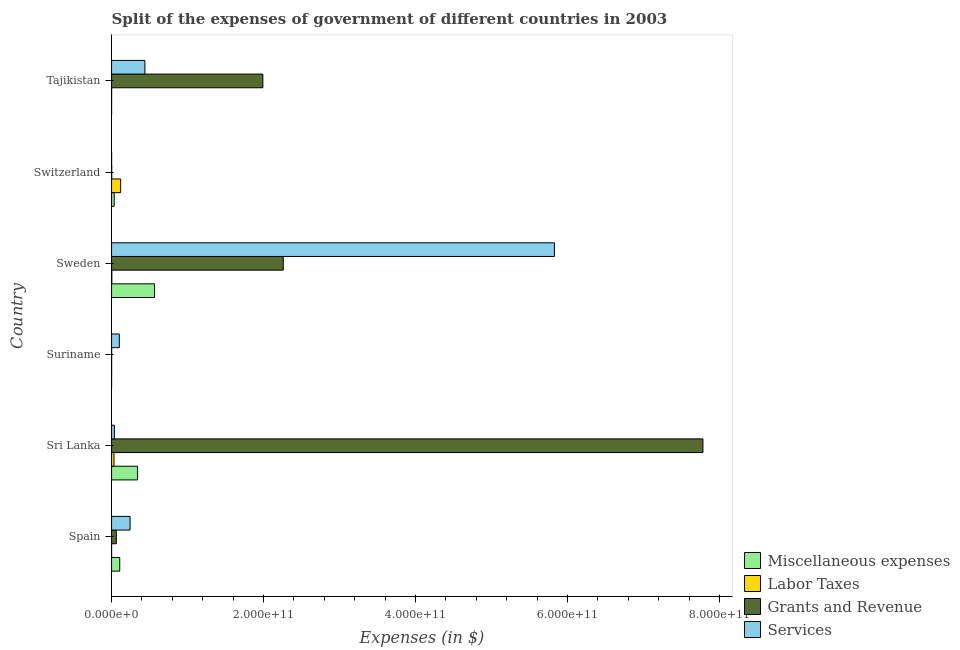How many different coloured bars are there?
Your response must be concise. 4. How many groups of bars are there?
Ensure brevity in your answer.  6. Are the number of bars per tick equal to the number of legend labels?
Make the answer very short. Yes. What is the label of the 2nd group of bars from the top?
Offer a very short reply. Switzerland. What is the amount spent on services in Sri Lanka?
Give a very brief answer. 3.75e+09. Across all countries, what is the maximum amount spent on labor taxes?
Your answer should be compact. 1.20e+1. Across all countries, what is the minimum amount spent on miscellaneous expenses?
Your answer should be compact. 4.59e+07. In which country was the amount spent on labor taxes maximum?
Ensure brevity in your answer.  Switzerland. In which country was the amount spent on grants and revenue minimum?
Offer a terse response. Suriname. What is the total amount spent on grants and revenue in the graph?
Offer a very short reply. 1.21e+12. What is the difference between the amount spent on services in Spain and that in Sri Lanka?
Ensure brevity in your answer.  2.06e+1. What is the difference between the amount spent on grants and revenue in Suriname and the amount spent on labor taxes in Tajikistan?
Ensure brevity in your answer.  3.47e+07. What is the average amount spent on labor taxes per country?
Give a very brief answer. 2.62e+09. What is the difference between the amount spent on grants and revenue and amount spent on labor taxes in Tajikistan?
Make the answer very short. 1.99e+11. In how many countries, is the amount spent on grants and revenue greater than 400000000000 $?
Provide a short and direct response. 1. What is the ratio of the amount spent on labor taxes in Switzerland to that in Tajikistan?
Keep it short and to the point. 125.86. Is the difference between the amount spent on grants and revenue in Sri Lanka and Sweden greater than the difference between the amount spent on services in Sri Lanka and Sweden?
Give a very brief answer. Yes. What is the difference between the highest and the second highest amount spent on services?
Your response must be concise. 5.39e+11. What is the difference between the highest and the lowest amount spent on services?
Keep it short and to the point. 5.83e+11. What does the 4th bar from the top in Spain represents?
Ensure brevity in your answer.  Miscellaneous expenses. What does the 3rd bar from the bottom in Sweden represents?
Ensure brevity in your answer.  Grants and Revenue. Are all the bars in the graph horizontal?
Make the answer very short. Yes. What is the difference between two consecutive major ticks on the X-axis?
Your answer should be compact. 2.00e+11. Does the graph contain any zero values?
Your answer should be compact. No. Does the graph contain grids?
Keep it short and to the point. No. Where does the legend appear in the graph?
Provide a short and direct response. Bottom right. How many legend labels are there?
Your response must be concise. 4. How are the legend labels stacked?
Keep it short and to the point. Vertical. What is the title of the graph?
Your answer should be compact. Split of the expenses of government of different countries in 2003. What is the label or title of the X-axis?
Provide a succinct answer. Expenses (in $). What is the label or title of the Y-axis?
Make the answer very short. Country. What is the Expenses (in $) in Miscellaneous expenses in Spain?
Keep it short and to the point. 1.08e+1. What is the Expenses (in $) in Labor Taxes in Spain?
Provide a short and direct response. 2.98e+07. What is the Expenses (in $) of Grants and Revenue in Spain?
Give a very brief answer. 6.27e+09. What is the Expenses (in $) in Services in Spain?
Offer a terse response. 2.44e+1. What is the Expenses (in $) of Miscellaneous expenses in Sri Lanka?
Your response must be concise. 3.42e+1. What is the Expenses (in $) of Labor Taxes in Sri Lanka?
Your response must be concise. 3.19e+09. What is the Expenses (in $) of Grants and Revenue in Sri Lanka?
Offer a very short reply. 7.78e+11. What is the Expenses (in $) in Services in Sri Lanka?
Offer a very short reply. 3.75e+09. What is the Expenses (in $) in Miscellaneous expenses in Suriname?
Your answer should be very brief. 4.59e+07. What is the Expenses (in $) of Labor Taxes in Suriname?
Offer a very short reply. 8.67e+07. What is the Expenses (in $) in Grants and Revenue in Suriname?
Keep it short and to the point. 1.30e+08. What is the Expenses (in $) of Services in Suriname?
Your response must be concise. 1.02e+1. What is the Expenses (in $) of Miscellaneous expenses in Sweden?
Your answer should be very brief. 5.66e+1. What is the Expenses (in $) of Labor Taxes in Sweden?
Make the answer very short. 3.64e+08. What is the Expenses (in $) in Grants and Revenue in Sweden?
Offer a terse response. 2.26e+11. What is the Expenses (in $) in Services in Sweden?
Offer a very short reply. 5.83e+11. What is the Expenses (in $) in Miscellaneous expenses in Switzerland?
Offer a terse response. 3.46e+09. What is the Expenses (in $) of Labor Taxes in Switzerland?
Offer a very short reply. 1.20e+1. What is the Expenses (in $) in Grants and Revenue in Switzerland?
Your response must be concise. 2.39e+08. What is the Expenses (in $) in Services in Switzerland?
Ensure brevity in your answer.  8.06e+07. What is the Expenses (in $) of Miscellaneous expenses in Tajikistan?
Provide a succinct answer. 5.62e+07. What is the Expenses (in $) of Labor Taxes in Tajikistan?
Your response must be concise. 9.50e+07. What is the Expenses (in $) of Grants and Revenue in Tajikistan?
Provide a short and direct response. 1.99e+11. What is the Expenses (in $) of Services in Tajikistan?
Keep it short and to the point. 4.39e+1. Across all countries, what is the maximum Expenses (in $) in Miscellaneous expenses?
Make the answer very short. 5.66e+1. Across all countries, what is the maximum Expenses (in $) of Labor Taxes?
Offer a terse response. 1.20e+1. Across all countries, what is the maximum Expenses (in $) of Grants and Revenue?
Your answer should be very brief. 7.78e+11. Across all countries, what is the maximum Expenses (in $) in Services?
Your response must be concise. 5.83e+11. Across all countries, what is the minimum Expenses (in $) in Miscellaneous expenses?
Offer a very short reply. 4.59e+07. Across all countries, what is the minimum Expenses (in $) of Labor Taxes?
Ensure brevity in your answer.  2.98e+07. Across all countries, what is the minimum Expenses (in $) of Grants and Revenue?
Offer a terse response. 1.30e+08. Across all countries, what is the minimum Expenses (in $) of Services?
Give a very brief answer. 8.06e+07. What is the total Expenses (in $) of Miscellaneous expenses in the graph?
Provide a succinct answer. 1.05e+11. What is the total Expenses (in $) of Labor Taxes in the graph?
Offer a terse response. 1.57e+1. What is the total Expenses (in $) of Grants and Revenue in the graph?
Your answer should be compact. 1.21e+12. What is the total Expenses (in $) of Services in the graph?
Your answer should be very brief. 6.65e+11. What is the difference between the Expenses (in $) in Miscellaneous expenses in Spain and that in Sri Lanka?
Your answer should be compact. -2.35e+1. What is the difference between the Expenses (in $) of Labor Taxes in Spain and that in Sri Lanka?
Your answer should be compact. -3.16e+09. What is the difference between the Expenses (in $) in Grants and Revenue in Spain and that in Sri Lanka?
Ensure brevity in your answer.  -7.72e+11. What is the difference between the Expenses (in $) of Services in Spain and that in Sri Lanka?
Keep it short and to the point. 2.06e+1. What is the difference between the Expenses (in $) of Miscellaneous expenses in Spain and that in Suriname?
Ensure brevity in your answer.  1.07e+1. What is the difference between the Expenses (in $) in Labor Taxes in Spain and that in Suriname?
Make the answer very short. -5.69e+07. What is the difference between the Expenses (in $) in Grants and Revenue in Spain and that in Suriname?
Ensure brevity in your answer.  6.14e+09. What is the difference between the Expenses (in $) of Services in Spain and that in Suriname?
Provide a short and direct response. 1.42e+1. What is the difference between the Expenses (in $) in Miscellaneous expenses in Spain and that in Sweden?
Provide a succinct answer. -4.58e+1. What is the difference between the Expenses (in $) in Labor Taxes in Spain and that in Sweden?
Your answer should be compact. -3.34e+08. What is the difference between the Expenses (in $) of Grants and Revenue in Spain and that in Sweden?
Ensure brevity in your answer.  -2.20e+11. What is the difference between the Expenses (in $) of Services in Spain and that in Sweden?
Offer a very short reply. -5.58e+11. What is the difference between the Expenses (in $) in Miscellaneous expenses in Spain and that in Switzerland?
Ensure brevity in your answer.  7.30e+09. What is the difference between the Expenses (in $) of Labor Taxes in Spain and that in Switzerland?
Offer a very short reply. -1.19e+1. What is the difference between the Expenses (in $) of Grants and Revenue in Spain and that in Switzerland?
Offer a very short reply. 6.04e+09. What is the difference between the Expenses (in $) of Services in Spain and that in Switzerland?
Give a very brief answer. 2.43e+1. What is the difference between the Expenses (in $) in Miscellaneous expenses in Spain and that in Tajikistan?
Offer a terse response. 1.07e+1. What is the difference between the Expenses (in $) in Labor Taxes in Spain and that in Tajikistan?
Your response must be concise. -6.52e+07. What is the difference between the Expenses (in $) of Grants and Revenue in Spain and that in Tajikistan?
Your response must be concise. -1.93e+11. What is the difference between the Expenses (in $) in Services in Spain and that in Tajikistan?
Make the answer very short. -1.95e+1. What is the difference between the Expenses (in $) of Miscellaneous expenses in Sri Lanka and that in Suriname?
Keep it short and to the point. 3.42e+1. What is the difference between the Expenses (in $) of Labor Taxes in Sri Lanka and that in Suriname?
Make the answer very short. 3.11e+09. What is the difference between the Expenses (in $) of Grants and Revenue in Sri Lanka and that in Suriname?
Your answer should be compact. 7.78e+11. What is the difference between the Expenses (in $) in Services in Sri Lanka and that in Suriname?
Give a very brief answer. -6.46e+09. What is the difference between the Expenses (in $) in Miscellaneous expenses in Sri Lanka and that in Sweden?
Give a very brief answer. -2.24e+1. What is the difference between the Expenses (in $) in Labor Taxes in Sri Lanka and that in Sweden?
Offer a terse response. 2.83e+09. What is the difference between the Expenses (in $) in Grants and Revenue in Sri Lanka and that in Sweden?
Ensure brevity in your answer.  5.52e+11. What is the difference between the Expenses (in $) of Services in Sri Lanka and that in Sweden?
Give a very brief answer. -5.79e+11. What is the difference between the Expenses (in $) of Miscellaneous expenses in Sri Lanka and that in Switzerland?
Give a very brief answer. 3.08e+1. What is the difference between the Expenses (in $) of Labor Taxes in Sri Lanka and that in Switzerland?
Give a very brief answer. -8.76e+09. What is the difference between the Expenses (in $) of Grants and Revenue in Sri Lanka and that in Switzerland?
Keep it short and to the point. 7.78e+11. What is the difference between the Expenses (in $) in Services in Sri Lanka and that in Switzerland?
Ensure brevity in your answer.  3.67e+09. What is the difference between the Expenses (in $) in Miscellaneous expenses in Sri Lanka and that in Tajikistan?
Ensure brevity in your answer.  3.42e+1. What is the difference between the Expenses (in $) of Labor Taxes in Sri Lanka and that in Tajikistan?
Your answer should be very brief. 3.10e+09. What is the difference between the Expenses (in $) of Grants and Revenue in Sri Lanka and that in Tajikistan?
Your answer should be very brief. 5.79e+11. What is the difference between the Expenses (in $) of Services in Sri Lanka and that in Tajikistan?
Provide a short and direct response. -4.01e+1. What is the difference between the Expenses (in $) in Miscellaneous expenses in Suriname and that in Sweden?
Keep it short and to the point. -5.65e+1. What is the difference between the Expenses (in $) of Labor Taxes in Suriname and that in Sweden?
Provide a short and direct response. -2.77e+08. What is the difference between the Expenses (in $) of Grants and Revenue in Suriname and that in Sweden?
Keep it short and to the point. -2.26e+11. What is the difference between the Expenses (in $) of Services in Suriname and that in Sweden?
Offer a terse response. -5.72e+11. What is the difference between the Expenses (in $) of Miscellaneous expenses in Suriname and that in Switzerland?
Give a very brief answer. -3.42e+09. What is the difference between the Expenses (in $) of Labor Taxes in Suriname and that in Switzerland?
Give a very brief answer. -1.19e+1. What is the difference between the Expenses (in $) of Grants and Revenue in Suriname and that in Switzerland?
Provide a short and direct response. -1.09e+08. What is the difference between the Expenses (in $) in Services in Suriname and that in Switzerland?
Your answer should be very brief. 1.01e+1. What is the difference between the Expenses (in $) of Miscellaneous expenses in Suriname and that in Tajikistan?
Provide a succinct answer. -1.03e+07. What is the difference between the Expenses (in $) of Labor Taxes in Suriname and that in Tajikistan?
Offer a terse response. -8.30e+06. What is the difference between the Expenses (in $) of Grants and Revenue in Suriname and that in Tajikistan?
Keep it short and to the point. -1.99e+11. What is the difference between the Expenses (in $) of Services in Suriname and that in Tajikistan?
Offer a very short reply. -3.37e+1. What is the difference between the Expenses (in $) of Miscellaneous expenses in Sweden and that in Switzerland?
Your answer should be compact. 5.31e+1. What is the difference between the Expenses (in $) in Labor Taxes in Sweden and that in Switzerland?
Give a very brief answer. -1.16e+1. What is the difference between the Expenses (in $) in Grants and Revenue in Sweden and that in Switzerland?
Your answer should be compact. 2.26e+11. What is the difference between the Expenses (in $) of Services in Sweden and that in Switzerland?
Your answer should be very brief. 5.83e+11. What is the difference between the Expenses (in $) of Miscellaneous expenses in Sweden and that in Tajikistan?
Offer a terse response. 5.65e+1. What is the difference between the Expenses (in $) in Labor Taxes in Sweden and that in Tajikistan?
Ensure brevity in your answer.  2.69e+08. What is the difference between the Expenses (in $) in Grants and Revenue in Sweden and that in Tajikistan?
Offer a terse response. 2.68e+1. What is the difference between the Expenses (in $) in Services in Sweden and that in Tajikistan?
Give a very brief answer. 5.39e+11. What is the difference between the Expenses (in $) in Miscellaneous expenses in Switzerland and that in Tajikistan?
Your answer should be very brief. 3.41e+09. What is the difference between the Expenses (in $) in Labor Taxes in Switzerland and that in Tajikistan?
Keep it short and to the point. 1.19e+1. What is the difference between the Expenses (in $) of Grants and Revenue in Switzerland and that in Tajikistan?
Make the answer very short. -1.99e+11. What is the difference between the Expenses (in $) in Services in Switzerland and that in Tajikistan?
Your answer should be very brief. -4.38e+1. What is the difference between the Expenses (in $) in Miscellaneous expenses in Spain and the Expenses (in $) in Labor Taxes in Sri Lanka?
Your response must be concise. 7.57e+09. What is the difference between the Expenses (in $) of Miscellaneous expenses in Spain and the Expenses (in $) of Grants and Revenue in Sri Lanka?
Give a very brief answer. -7.67e+11. What is the difference between the Expenses (in $) in Miscellaneous expenses in Spain and the Expenses (in $) in Services in Sri Lanka?
Your answer should be very brief. 7.01e+09. What is the difference between the Expenses (in $) in Labor Taxes in Spain and the Expenses (in $) in Grants and Revenue in Sri Lanka?
Provide a short and direct response. -7.78e+11. What is the difference between the Expenses (in $) of Labor Taxes in Spain and the Expenses (in $) of Services in Sri Lanka?
Provide a short and direct response. -3.72e+09. What is the difference between the Expenses (in $) of Grants and Revenue in Spain and the Expenses (in $) of Services in Sri Lanka?
Provide a succinct answer. 2.52e+09. What is the difference between the Expenses (in $) in Miscellaneous expenses in Spain and the Expenses (in $) in Labor Taxes in Suriname?
Your response must be concise. 1.07e+1. What is the difference between the Expenses (in $) of Miscellaneous expenses in Spain and the Expenses (in $) of Grants and Revenue in Suriname?
Your answer should be compact. 1.06e+1. What is the difference between the Expenses (in $) in Miscellaneous expenses in Spain and the Expenses (in $) in Services in Suriname?
Offer a terse response. 5.50e+08. What is the difference between the Expenses (in $) of Labor Taxes in Spain and the Expenses (in $) of Grants and Revenue in Suriname?
Provide a short and direct response. -9.99e+07. What is the difference between the Expenses (in $) in Labor Taxes in Spain and the Expenses (in $) in Services in Suriname?
Provide a succinct answer. -1.02e+1. What is the difference between the Expenses (in $) in Grants and Revenue in Spain and the Expenses (in $) in Services in Suriname?
Give a very brief answer. -3.94e+09. What is the difference between the Expenses (in $) of Miscellaneous expenses in Spain and the Expenses (in $) of Labor Taxes in Sweden?
Make the answer very short. 1.04e+1. What is the difference between the Expenses (in $) of Miscellaneous expenses in Spain and the Expenses (in $) of Grants and Revenue in Sweden?
Offer a very short reply. -2.15e+11. What is the difference between the Expenses (in $) of Miscellaneous expenses in Spain and the Expenses (in $) of Services in Sweden?
Keep it short and to the point. -5.72e+11. What is the difference between the Expenses (in $) in Labor Taxes in Spain and the Expenses (in $) in Grants and Revenue in Sweden?
Your response must be concise. -2.26e+11. What is the difference between the Expenses (in $) of Labor Taxes in Spain and the Expenses (in $) of Services in Sweden?
Your answer should be very brief. -5.83e+11. What is the difference between the Expenses (in $) of Grants and Revenue in Spain and the Expenses (in $) of Services in Sweden?
Offer a terse response. -5.76e+11. What is the difference between the Expenses (in $) of Miscellaneous expenses in Spain and the Expenses (in $) of Labor Taxes in Switzerland?
Make the answer very short. -1.20e+09. What is the difference between the Expenses (in $) of Miscellaneous expenses in Spain and the Expenses (in $) of Grants and Revenue in Switzerland?
Give a very brief answer. 1.05e+1. What is the difference between the Expenses (in $) of Miscellaneous expenses in Spain and the Expenses (in $) of Services in Switzerland?
Ensure brevity in your answer.  1.07e+1. What is the difference between the Expenses (in $) of Labor Taxes in Spain and the Expenses (in $) of Grants and Revenue in Switzerland?
Offer a terse response. -2.09e+08. What is the difference between the Expenses (in $) in Labor Taxes in Spain and the Expenses (in $) in Services in Switzerland?
Provide a succinct answer. -5.08e+07. What is the difference between the Expenses (in $) of Grants and Revenue in Spain and the Expenses (in $) of Services in Switzerland?
Keep it short and to the point. 6.19e+09. What is the difference between the Expenses (in $) of Miscellaneous expenses in Spain and the Expenses (in $) of Labor Taxes in Tajikistan?
Give a very brief answer. 1.07e+1. What is the difference between the Expenses (in $) in Miscellaneous expenses in Spain and the Expenses (in $) in Grants and Revenue in Tajikistan?
Make the answer very short. -1.88e+11. What is the difference between the Expenses (in $) in Miscellaneous expenses in Spain and the Expenses (in $) in Services in Tajikistan?
Keep it short and to the point. -3.31e+1. What is the difference between the Expenses (in $) of Labor Taxes in Spain and the Expenses (in $) of Grants and Revenue in Tajikistan?
Offer a terse response. -1.99e+11. What is the difference between the Expenses (in $) in Labor Taxes in Spain and the Expenses (in $) in Services in Tajikistan?
Your answer should be compact. -4.38e+1. What is the difference between the Expenses (in $) in Grants and Revenue in Spain and the Expenses (in $) in Services in Tajikistan?
Provide a succinct answer. -3.76e+1. What is the difference between the Expenses (in $) of Miscellaneous expenses in Sri Lanka and the Expenses (in $) of Labor Taxes in Suriname?
Keep it short and to the point. 3.41e+1. What is the difference between the Expenses (in $) of Miscellaneous expenses in Sri Lanka and the Expenses (in $) of Grants and Revenue in Suriname?
Your response must be concise. 3.41e+1. What is the difference between the Expenses (in $) in Miscellaneous expenses in Sri Lanka and the Expenses (in $) in Services in Suriname?
Your answer should be very brief. 2.40e+1. What is the difference between the Expenses (in $) of Labor Taxes in Sri Lanka and the Expenses (in $) of Grants and Revenue in Suriname?
Provide a succinct answer. 3.06e+09. What is the difference between the Expenses (in $) of Labor Taxes in Sri Lanka and the Expenses (in $) of Services in Suriname?
Provide a short and direct response. -7.02e+09. What is the difference between the Expenses (in $) in Grants and Revenue in Sri Lanka and the Expenses (in $) in Services in Suriname?
Keep it short and to the point. 7.68e+11. What is the difference between the Expenses (in $) of Miscellaneous expenses in Sri Lanka and the Expenses (in $) of Labor Taxes in Sweden?
Your answer should be very brief. 3.39e+1. What is the difference between the Expenses (in $) in Miscellaneous expenses in Sri Lanka and the Expenses (in $) in Grants and Revenue in Sweden?
Keep it short and to the point. -1.92e+11. What is the difference between the Expenses (in $) in Miscellaneous expenses in Sri Lanka and the Expenses (in $) in Services in Sweden?
Offer a very short reply. -5.48e+11. What is the difference between the Expenses (in $) of Labor Taxes in Sri Lanka and the Expenses (in $) of Grants and Revenue in Sweden?
Keep it short and to the point. -2.23e+11. What is the difference between the Expenses (in $) in Labor Taxes in Sri Lanka and the Expenses (in $) in Services in Sweden?
Keep it short and to the point. -5.79e+11. What is the difference between the Expenses (in $) of Grants and Revenue in Sri Lanka and the Expenses (in $) of Services in Sweden?
Provide a short and direct response. 1.95e+11. What is the difference between the Expenses (in $) of Miscellaneous expenses in Sri Lanka and the Expenses (in $) of Labor Taxes in Switzerland?
Ensure brevity in your answer.  2.23e+1. What is the difference between the Expenses (in $) of Miscellaneous expenses in Sri Lanka and the Expenses (in $) of Grants and Revenue in Switzerland?
Your answer should be very brief. 3.40e+1. What is the difference between the Expenses (in $) of Miscellaneous expenses in Sri Lanka and the Expenses (in $) of Services in Switzerland?
Make the answer very short. 3.42e+1. What is the difference between the Expenses (in $) of Labor Taxes in Sri Lanka and the Expenses (in $) of Grants and Revenue in Switzerland?
Your response must be concise. 2.96e+09. What is the difference between the Expenses (in $) of Labor Taxes in Sri Lanka and the Expenses (in $) of Services in Switzerland?
Ensure brevity in your answer.  3.11e+09. What is the difference between the Expenses (in $) in Grants and Revenue in Sri Lanka and the Expenses (in $) in Services in Switzerland?
Ensure brevity in your answer.  7.78e+11. What is the difference between the Expenses (in $) in Miscellaneous expenses in Sri Lanka and the Expenses (in $) in Labor Taxes in Tajikistan?
Your response must be concise. 3.41e+1. What is the difference between the Expenses (in $) of Miscellaneous expenses in Sri Lanka and the Expenses (in $) of Grants and Revenue in Tajikistan?
Make the answer very short. -1.65e+11. What is the difference between the Expenses (in $) in Miscellaneous expenses in Sri Lanka and the Expenses (in $) in Services in Tajikistan?
Offer a terse response. -9.63e+09. What is the difference between the Expenses (in $) in Labor Taxes in Sri Lanka and the Expenses (in $) in Grants and Revenue in Tajikistan?
Offer a terse response. -1.96e+11. What is the difference between the Expenses (in $) in Labor Taxes in Sri Lanka and the Expenses (in $) in Services in Tajikistan?
Provide a succinct answer. -4.07e+1. What is the difference between the Expenses (in $) in Grants and Revenue in Sri Lanka and the Expenses (in $) in Services in Tajikistan?
Make the answer very short. 7.34e+11. What is the difference between the Expenses (in $) of Miscellaneous expenses in Suriname and the Expenses (in $) of Labor Taxes in Sweden?
Your answer should be compact. -3.18e+08. What is the difference between the Expenses (in $) of Miscellaneous expenses in Suriname and the Expenses (in $) of Grants and Revenue in Sweden?
Your answer should be very brief. -2.26e+11. What is the difference between the Expenses (in $) of Miscellaneous expenses in Suriname and the Expenses (in $) of Services in Sweden?
Keep it short and to the point. -5.83e+11. What is the difference between the Expenses (in $) of Labor Taxes in Suriname and the Expenses (in $) of Grants and Revenue in Sweden?
Provide a short and direct response. -2.26e+11. What is the difference between the Expenses (in $) of Labor Taxes in Suriname and the Expenses (in $) of Services in Sweden?
Make the answer very short. -5.83e+11. What is the difference between the Expenses (in $) of Grants and Revenue in Suriname and the Expenses (in $) of Services in Sweden?
Make the answer very short. -5.83e+11. What is the difference between the Expenses (in $) of Miscellaneous expenses in Suriname and the Expenses (in $) of Labor Taxes in Switzerland?
Your response must be concise. -1.19e+1. What is the difference between the Expenses (in $) of Miscellaneous expenses in Suriname and the Expenses (in $) of Grants and Revenue in Switzerland?
Give a very brief answer. -1.93e+08. What is the difference between the Expenses (in $) in Miscellaneous expenses in Suriname and the Expenses (in $) in Services in Switzerland?
Ensure brevity in your answer.  -3.48e+07. What is the difference between the Expenses (in $) in Labor Taxes in Suriname and the Expenses (in $) in Grants and Revenue in Switzerland?
Your answer should be compact. -1.52e+08. What is the difference between the Expenses (in $) in Labor Taxes in Suriname and the Expenses (in $) in Services in Switzerland?
Give a very brief answer. 6.08e+06. What is the difference between the Expenses (in $) in Grants and Revenue in Suriname and the Expenses (in $) in Services in Switzerland?
Give a very brief answer. 4.91e+07. What is the difference between the Expenses (in $) in Miscellaneous expenses in Suriname and the Expenses (in $) in Labor Taxes in Tajikistan?
Your answer should be compact. -4.91e+07. What is the difference between the Expenses (in $) in Miscellaneous expenses in Suriname and the Expenses (in $) in Grants and Revenue in Tajikistan?
Offer a terse response. -1.99e+11. What is the difference between the Expenses (in $) in Miscellaneous expenses in Suriname and the Expenses (in $) in Services in Tajikistan?
Ensure brevity in your answer.  -4.38e+1. What is the difference between the Expenses (in $) of Labor Taxes in Suriname and the Expenses (in $) of Grants and Revenue in Tajikistan?
Provide a succinct answer. -1.99e+11. What is the difference between the Expenses (in $) in Labor Taxes in Suriname and the Expenses (in $) in Services in Tajikistan?
Provide a succinct answer. -4.38e+1. What is the difference between the Expenses (in $) in Grants and Revenue in Suriname and the Expenses (in $) in Services in Tajikistan?
Make the answer very short. -4.37e+1. What is the difference between the Expenses (in $) of Miscellaneous expenses in Sweden and the Expenses (in $) of Labor Taxes in Switzerland?
Provide a succinct answer. 4.46e+1. What is the difference between the Expenses (in $) in Miscellaneous expenses in Sweden and the Expenses (in $) in Grants and Revenue in Switzerland?
Keep it short and to the point. 5.64e+1. What is the difference between the Expenses (in $) in Miscellaneous expenses in Sweden and the Expenses (in $) in Services in Switzerland?
Ensure brevity in your answer.  5.65e+1. What is the difference between the Expenses (in $) in Labor Taxes in Sweden and the Expenses (in $) in Grants and Revenue in Switzerland?
Offer a very short reply. 1.25e+08. What is the difference between the Expenses (in $) in Labor Taxes in Sweden and the Expenses (in $) in Services in Switzerland?
Your answer should be very brief. 2.83e+08. What is the difference between the Expenses (in $) in Grants and Revenue in Sweden and the Expenses (in $) in Services in Switzerland?
Keep it short and to the point. 2.26e+11. What is the difference between the Expenses (in $) of Miscellaneous expenses in Sweden and the Expenses (in $) of Labor Taxes in Tajikistan?
Provide a succinct answer. 5.65e+1. What is the difference between the Expenses (in $) of Miscellaneous expenses in Sweden and the Expenses (in $) of Grants and Revenue in Tajikistan?
Your answer should be very brief. -1.42e+11. What is the difference between the Expenses (in $) of Miscellaneous expenses in Sweden and the Expenses (in $) of Services in Tajikistan?
Your response must be concise. 1.27e+1. What is the difference between the Expenses (in $) in Labor Taxes in Sweden and the Expenses (in $) in Grants and Revenue in Tajikistan?
Offer a very short reply. -1.99e+11. What is the difference between the Expenses (in $) in Labor Taxes in Sweden and the Expenses (in $) in Services in Tajikistan?
Provide a succinct answer. -4.35e+1. What is the difference between the Expenses (in $) of Grants and Revenue in Sweden and the Expenses (in $) of Services in Tajikistan?
Ensure brevity in your answer.  1.82e+11. What is the difference between the Expenses (in $) of Miscellaneous expenses in Switzerland and the Expenses (in $) of Labor Taxes in Tajikistan?
Make the answer very short. 3.37e+09. What is the difference between the Expenses (in $) of Miscellaneous expenses in Switzerland and the Expenses (in $) of Grants and Revenue in Tajikistan?
Your response must be concise. -1.96e+11. What is the difference between the Expenses (in $) in Miscellaneous expenses in Switzerland and the Expenses (in $) in Services in Tajikistan?
Give a very brief answer. -4.04e+1. What is the difference between the Expenses (in $) of Labor Taxes in Switzerland and the Expenses (in $) of Grants and Revenue in Tajikistan?
Give a very brief answer. -1.87e+11. What is the difference between the Expenses (in $) in Labor Taxes in Switzerland and the Expenses (in $) in Services in Tajikistan?
Your answer should be compact. -3.19e+1. What is the difference between the Expenses (in $) of Grants and Revenue in Switzerland and the Expenses (in $) of Services in Tajikistan?
Offer a terse response. -4.36e+1. What is the average Expenses (in $) of Miscellaneous expenses per country?
Ensure brevity in your answer.  1.75e+1. What is the average Expenses (in $) in Labor Taxes per country?
Your answer should be very brief. 2.62e+09. What is the average Expenses (in $) of Grants and Revenue per country?
Your answer should be very brief. 2.02e+11. What is the average Expenses (in $) in Services per country?
Provide a short and direct response. 1.11e+11. What is the difference between the Expenses (in $) of Miscellaneous expenses and Expenses (in $) of Labor Taxes in Spain?
Give a very brief answer. 1.07e+1. What is the difference between the Expenses (in $) of Miscellaneous expenses and Expenses (in $) of Grants and Revenue in Spain?
Ensure brevity in your answer.  4.49e+09. What is the difference between the Expenses (in $) in Miscellaneous expenses and Expenses (in $) in Services in Spain?
Ensure brevity in your answer.  -1.36e+1. What is the difference between the Expenses (in $) of Labor Taxes and Expenses (in $) of Grants and Revenue in Spain?
Keep it short and to the point. -6.24e+09. What is the difference between the Expenses (in $) of Labor Taxes and Expenses (in $) of Services in Spain?
Make the answer very short. -2.43e+1. What is the difference between the Expenses (in $) in Grants and Revenue and Expenses (in $) in Services in Spain?
Your answer should be compact. -1.81e+1. What is the difference between the Expenses (in $) in Miscellaneous expenses and Expenses (in $) in Labor Taxes in Sri Lanka?
Your answer should be compact. 3.10e+1. What is the difference between the Expenses (in $) in Miscellaneous expenses and Expenses (in $) in Grants and Revenue in Sri Lanka?
Provide a short and direct response. -7.44e+11. What is the difference between the Expenses (in $) in Miscellaneous expenses and Expenses (in $) in Services in Sri Lanka?
Provide a short and direct response. 3.05e+1. What is the difference between the Expenses (in $) in Labor Taxes and Expenses (in $) in Grants and Revenue in Sri Lanka?
Offer a very short reply. -7.75e+11. What is the difference between the Expenses (in $) of Labor Taxes and Expenses (in $) of Services in Sri Lanka?
Offer a terse response. -5.60e+08. What is the difference between the Expenses (in $) in Grants and Revenue and Expenses (in $) in Services in Sri Lanka?
Keep it short and to the point. 7.74e+11. What is the difference between the Expenses (in $) of Miscellaneous expenses and Expenses (in $) of Labor Taxes in Suriname?
Your answer should be very brief. -4.08e+07. What is the difference between the Expenses (in $) in Miscellaneous expenses and Expenses (in $) in Grants and Revenue in Suriname?
Your response must be concise. -8.39e+07. What is the difference between the Expenses (in $) in Miscellaneous expenses and Expenses (in $) in Services in Suriname?
Your answer should be compact. -1.02e+1. What is the difference between the Expenses (in $) in Labor Taxes and Expenses (in $) in Grants and Revenue in Suriname?
Make the answer very short. -4.30e+07. What is the difference between the Expenses (in $) of Labor Taxes and Expenses (in $) of Services in Suriname?
Offer a very short reply. -1.01e+1. What is the difference between the Expenses (in $) of Grants and Revenue and Expenses (in $) of Services in Suriname?
Offer a very short reply. -1.01e+1. What is the difference between the Expenses (in $) in Miscellaneous expenses and Expenses (in $) in Labor Taxes in Sweden?
Make the answer very short. 5.62e+1. What is the difference between the Expenses (in $) of Miscellaneous expenses and Expenses (in $) of Grants and Revenue in Sweden?
Give a very brief answer. -1.69e+11. What is the difference between the Expenses (in $) in Miscellaneous expenses and Expenses (in $) in Services in Sweden?
Offer a very short reply. -5.26e+11. What is the difference between the Expenses (in $) in Labor Taxes and Expenses (in $) in Grants and Revenue in Sweden?
Give a very brief answer. -2.26e+11. What is the difference between the Expenses (in $) in Labor Taxes and Expenses (in $) in Services in Sweden?
Your response must be concise. -5.82e+11. What is the difference between the Expenses (in $) of Grants and Revenue and Expenses (in $) of Services in Sweden?
Make the answer very short. -3.57e+11. What is the difference between the Expenses (in $) of Miscellaneous expenses and Expenses (in $) of Labor Taxes in Switzerland?
Provide a short and direct response. -8.49e+09. What is the difference between the Expenses (in $) in Miscellaneous expenses and Expenses (in $) in Grants and Revenue in Switzerland?
Offer a terse response. 3.22e+09. What is the difference between the Expenses (in $) of Miscellaneous expenses and Expenses (in $) of Services in Switzerland?
Your answer should be very brief. 3.38e+09. What is the difference between the Expenses (in $) in Labor Taxes and Expenses (in $) in Grants and Revenue in Switzerland?
Provide a succinct answer. 1.17e+1. What is the difference between the Expenses (in $) of Labor Taxes and Expenses (in $) of Services in Switzerland?
Your answer should be very brief. 1.19e+1. What is the difference between the Expenses (in $) in Grants and Revenue and Expenses (in $) in Services in Switzerland?
Offer a very short reply. 1.58e+08. What is the difference between the Expenses (in $) of Miscellaneous expenses and Expenses (in $) of Labor Taxes in Tajikistan?
Make the answer very short. -3.88e+07. What is the difference between the Expenses (in $) in Miscellaneous expenses and Expenses (in $) in Grants and Revenue in Tajikistan?
Your answer should be compact. -1.99e+11. What is the difference between the Expenses (in $) in Miscellaneous expenses and Expenses (in $) in Services in Tajikistan?
Offer a very short reply. -4.38e+1. What is the difference between the Expenses (in $) in Labor Taxes and Expenses (in $) in Grants and Revenue in Tajikistan?
Provide a short and direct response. -1.99e+11. What is the difference between the Expenses (in $) in Labor Taxes and Expenses (in $) in Services in Tajikistan?
Offer a very short reply. -4.38e+1. What is the difference between the Expenses (in $) in Grants and Revenue and Expenses (in $) in Services in Tajikistan?
Offer a terse response. 1.55e+11. What is the ratio of the Expenses (in $) of Miscellaneous expenses in Spain to that in Sri Lanka?
Keep it short and to the point. 0.31. What is the ratio of the Expenses (in $) in Labor Taxes in Spain to that in Sri Lanka?
Your answer should be very brief. 0.01. What is the ratio of the Expenses (in $) of Grants and Revenue in Spain to that in Sri Lanka?
Your answer should be compact. 0.01. What is the ratio of the Expenses (in $) of Services in Spain to that in Sri Lanka?
Give a very brief answer. 6.49. What is the ratio of the Expenses (in $) of Miscellaneous expenses in Spain to that in Suriname?
Keep it short and to the point. 234.65. What is the ratio of the Expenses (in $) in Labor Taxes in Spain to that in Suriname?
Make the answer very short. 0.34. What is the ratio of the Expenses (in $) in Grants and Revenue in Spain to that in Suriname?
Give a very brief answer. 48.36. What is the ratio of the Expenses (in $) in Services in Spain to that in Suriname?
Provide a short and direct response. 2.39. What is the ratio of the Expenses (in $) of Miscellaneous expenses in Spain to that in Sweden?
Your answer should be compact. 0.19. What is the ratio of the Expenses (in $) in Labor Taxes in Spain to that in Sweden?
Offer a terse response. 0.08. What is the ratio of the Expenses (in $) in Grants and Revenue in Spain to that in Sweden?
Offer a terse response. 0.03. What is the ratio of the Expenses (in $) in Services in Spain to that in Sweden?
Your answer should be very brief. 0.04. What is the ratio of the Expenses (in $) in Miscellaneous expenses in Spain to that in Switzerland?
Ensure brevity in your answer.  3.11. What is the ratio of the Expenses (in $) of Labor Taxes in Spain to that in Switzerland?
Your answer should be compact. 0. What is the ratio of the Expenses (in $) of Grants and Revenue in Spain to that in Switzerland?
Your answer should be very brief. 26.28. What is the ratio of the Expenses (in $) of Services in Spain to that in Switzerland?
Offer a very short reply. 302.29. What is the ratio of the Expenses (in $) of Miscellaneous expenses in Spain to that in Tajikistan?
Offer a very short reply. 191.53. What is the ratio of the Expenses (in $) in Labor Taxes in Spain to that in Tajikistan?
Keep it short and to the point. 0.31. What is the ratio of the Expenses (in $) in Grants and Revenue in Spain to that in Tajikistan?
Your answer should be compact. 0.03. What is the ratio of the Expenses (in $) of Services in Spain to that in Tajikistan?
Ensure brevity in your answer.  0.56. What is the ratio of the Expenses (in $) of Miscellaneous expenses in Sri Lanka to that in Suriname?
Keep it short and to the point. 746.48. What is the ratio of the Expenses (in $) in Labor Taxes in Sri Lanka to that in Suriname?
Provide a succinct answer. 36.84. What is the ratio of the Expenses (in $) of Grants and Revenue in Sri Lanka to that in Suriname?
Provide a short and direct response. 5997.63. What is the ratio of the Expenses (in $) in Services in Sri Lanka to that in Suriname?
Offer a very short reply. 0.37. What is the ratio of the Expenses (in $) of Miscellaneous expenses in Sri Lanka to that in Sweden?
Keep it short and to the point. 0.6. What is the ratio of the Expenses (in $) of Labor Taxes in Sri Lanka to that in Sweden?
Your answer should be very brief. 8.79. What is the ratio of the Expenses (in $) in Grants and Revenue in Sri Lanka to that in Sweden?
Ensure brevity in your answer.  3.44. What is the ratio of the Expenses (in $) of Services in Sri Lanka to that in Sweden?
Offer a terse response. 0.01. What is the ratio of the Expenses (in $) of Miscellaneous expenses in Sri Lanka to that in Switzerland?
Your answer should be very brief. 9.89. What is the ratio of the Expenses (in $) in Labor Taxes in Sri Lanka to that in Switzerland?
Make the answer very short. 0.27. What is the ratio of the Expenses (in $) of Grants and Revenue in Sri Lanka to that in Switzerland?
Give a very brief answer. 3259.69. What is the ratio of the Expenses (in $) in Services in Sri Lanka to that in Switzerland?
Keep it short and to the point. 46.56. What is the ratio of the Expenses (in $) in Miscellaneous expenses in Sri Lanka to that in Tajikistan?
Ensure brevity in your answer.  609.29. What is the ratio of the Expenses (in $) of Labor Taxes in Sri Lanka to that in Tajikistan?
Your answer should be very brief. 33.62. What is the ratio of the Expenses (in $) of Grants and Revenue in Sri Lanka to that in Tajikistan?
Provide a short and direct response. 3.91. What is the ratio of the Expenses (in $) of Services in Sri Lanka to that in Tajikistan?
Your answer should be very brief. 0.09. What is the ratio of the Expenses (in $) in Miscellaneous expenses in Suriname to that in Sweden?
Make the answer very short. 0. What is the ratio of the Expenses (in $) of Labor Taxes in Suriname to that in Sweden?
Offer a terse response. 0.24. What is the ratio of the Expenses (in $) in Grants and Revenue in Suriname to that in Sweden?
Offer a terse response. 0. What is the ratio of the Expenses (in $) in Services in Suriname to that in Sweden?
Give a very brief answer. 0.02. What is the ratio of the Expenses (in $) in Miscellaneous expenses in Suriname to that in Switzerland?
Offer a very short reply. 0.01. What is the ratio of the Expenses (in $) of Labor Taxes in Suriname to that in Switzerland?
Offer a very short reply. 0.01. What is the ratio of the Expenses (in $) of Grants and Revenue in Suriname to that in Switzerland?
Keep it short and to the point. 0.54. What is the ratio of the Expenses (in $) of Services in Suriname to that in Switzerland?
Offer a terse response. 126.65. What is the ratio of the Expenses (in $) of Miscellaneous expenses in Suriname to that in Tajikistan?
Provide a short and direct response. 0.82. What is the ratio of the Expenses (in $) of Labor Taxes in Suriname to that in Tajikistan?
Offer a very short reply. 0.91. What is the ratio of the Expenses (in $) of Grants and Revenue in Suriname to that in Tajikistan?
Your answer should be very brief. 0. What is the ratio of the Expenses (in $) of Services in Suriname to that in Tajikistan?
Your answer should be very brief. 0.23. What is the ratio of the Expenses (in $) of Miscellaneous expenses in Sweden to that in Switzerland?
Provide a succinct answer. 16.34. What is the ratio of the Expenses (in $) of Labor Taxes in Sweden to that in Switzerland?
Make the answer very short. 0.03. What is the ratio of the Expenses (in $) in Grants and Revenue in Sweden to that in Switzerland?
Keep it short and to the point. 946.27. What is the ratio of the Expenses (in $) in Services in Sweden to that in Switzerland?
Your response must be concise. 7227.2. What is the ratio of the Expenses (in $) of Miscellaneous expenses in Sweden to that in Tajikistan?
Offer a terse response. 1007.26. What is the ratio of the Expenses (in $) of Labor Taxes in Sweden to that in Tajikistan?
Your answer should be very brief. 3.83. What is the ratio of the Expenses (in $) in Grants and Revenue in Sweden to that in Tajikistan?
Your answer should be compact. 1.13. What is the ratio of the Expenses (in $) in Services in Sweden to that in Tajikistan?
Provide a succinct answer. 13.28. What is the ratio of the Expenses (in $) in Miscellaneous expenses in Switzerland to that in Tajikistan?
Your response must be concise. 61.64. What is the ratio of the Expenses (in $) of Labor Taxes in Switzerland to that in Tajikistan?
Offer a terse response. 125.86. What is the ratio of the Expenses (in $) of Grants and Revenue in Switzerland to that in Tajikistan?
Your answer should be very brief. 0. What is the ratio of the Expenses (in $) of Services in Switzerland to that in Tajikistan?
Give a very brief answer. 0. What is the difference between the highest and the second highest Expenses (in $) of Miscellaneous expenses?
Offer a very short reply. 2.24e+1. What is the difference between the highest and the second highest Expenses (in $) of Labor Taxes?
Your answer should be compact. 8.76e+09. What is the difference between the highest and the second highest Expenses (in $) in Grants and Revenue?
Provide a short and direct response. 5.52e+11. What is the difference between the highest and the second highest Expenses (in $) in Services?
Give a very brief answer. 5.39e+11. What is the difference between the highest and the lowest Expenses (in $) of Miscellaneous expenses?
Give a very brief answer. 5.65e+1. What is the difference between the highest and the lowest Expenses (in $) in Labor Taxes?
Offer a very short reply. 1.19e+1. What is the difference between the highest and the lowest Expenses (in $) of Grants and Revenue?
Offer a terse response. 7.78e+11. What is the difference between the highest and the lowest Expenses (in $) in Services?
Your answer should be very brief. 5.83e+11. 